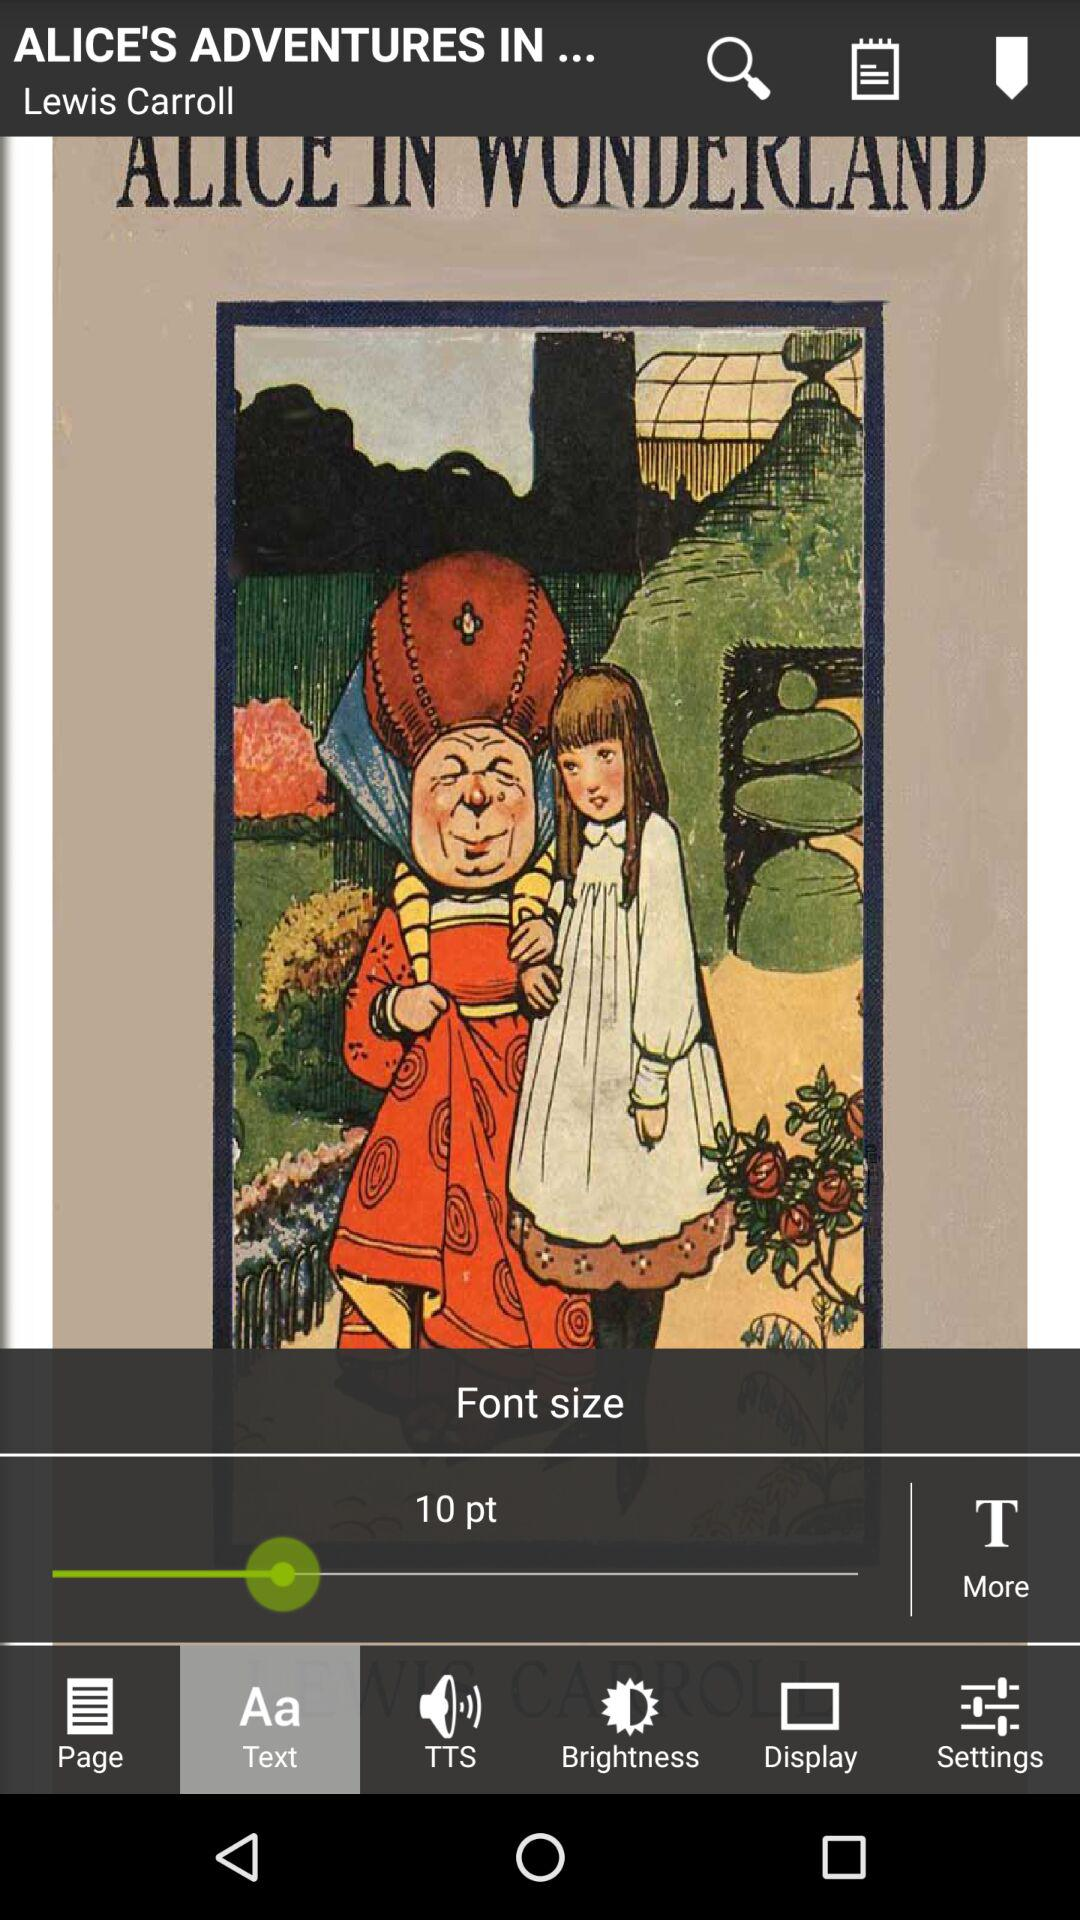Who is the author of "ALICE IN WONDERLAND"? The author of "ALICE IN WONDERLAND" is Lewis Carroll. 